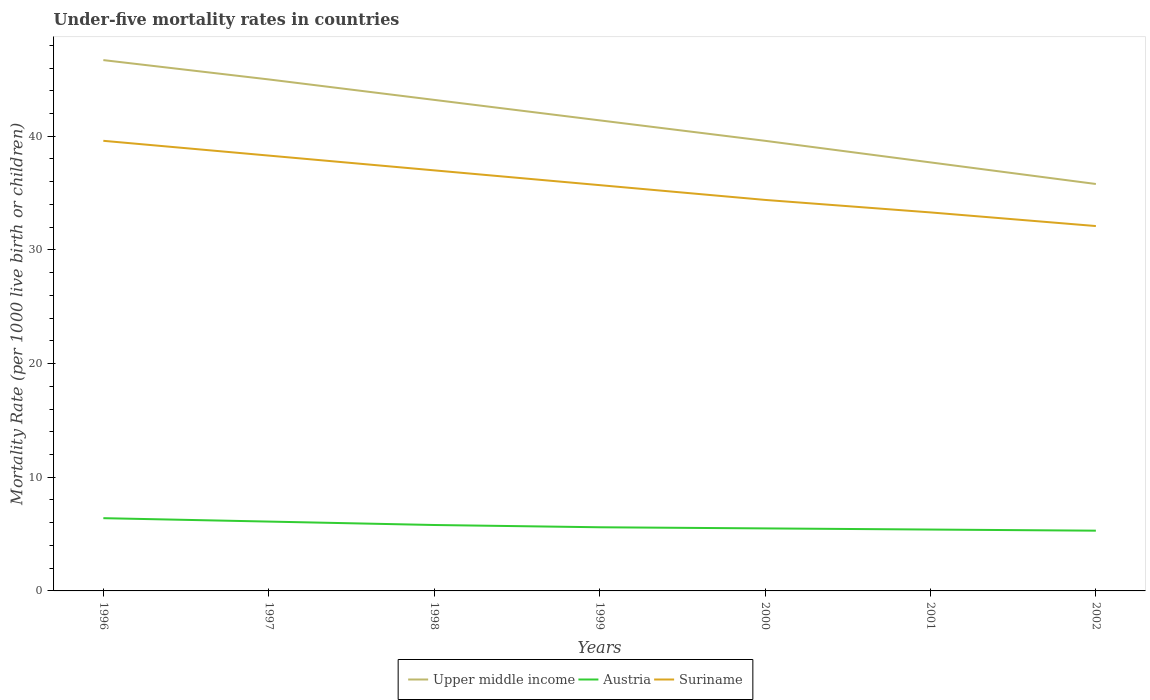How many different coloured lines are there?
Your answer should be compact. 3. Does the line corresponding to Austria intersect with the line corresponding to Suriname?
Offer a very short reply. No. Is the number of lines equal to the number of legend labels?
Make the answer very short. Yes. Across all years, what is the maximum under-five mortality rate in Suriname?
Give a very brief answer. 32.1. What is the total under-five mortality rate in Upper middle income in the graph?
Ensure brevity in your answer.  3.6. What is the difference between the highest and the second highest under-five mortality rate in Austria?
Give a very brief answer. 1.1. How many years are there in the graph?
Give a very brief answer. 7. Does the graph contain grids?
Provide a succinct answer. No. Where does the legend appear in the graph?
Provide a succinct answer. Bottom center. How many legend labels are there?
Provide a succinct answer. 3. How are the legend labels stacked?
Keep it short and to the point. Horizontal. What is the title of the graph?
Your answer should be compact. Under-five mortality rates in countries. Does "Bolivia" appear as one of the legend labels in the graph?
Your response must be concise. No. What is the label or title of the Y-axis?
Make the answer very short. Mortality Rate (per 1000 live birth or children). What is the Mortality Rate (per 1000 live birth or children) of Upper middle income in 1996?
Keep it short and to the point. 46.7. What is the Mortality Rate (per 1000 live birth or children) in Austria in 1996?
Ensure brevity in your answer.  6.4. What is the Mortality Rate (per 1000 live birth or children) in Suriname in 1996?
Provide a succinct answer. 39.6. What is the Mortality Rate (per 1000 live birth or children) of Upper middle income in 1997?
Provide a short and direct response. 45. What is the Mortality Rate (per 1000 live birth or children) of Suriname in 1997?
Offer a terse response. 38.3. What is the Mortality Rate (per 1000 live birth or children) of Upper middle income in 1998?
Make the answer very short. 43.2. What is the Mortality Rate (per 1000 live birth or children) in Suriname in 1998?
Make the answer very short. 37. What is the Mortality Rate (per 1000 live birth or children) in Upper middle income in 1999?
Provide a short and direct response. 41.4. What is the Mortality Rate (per 1000 live birth or children) in Austria in 1999?
Provide a short and direct response. 5.6. What is the Mortality Rate (per 1000 live birth or children) in Suriname in 1999?
Offer a very short reply. 35.7. What is the Mortality Rate (per 1000 live birth or children) of Upper middle income in 2000?
Your answer should be very brief. 39.6. What is the Mortality Rate (per 1000 live birth or children) in Suriname in 2000?
Your answer should be compact. 34.4. What is the Mortality Rate (per 1000 live birth or children) in Upper middle income in 2001?
Provide a succinct answer. 37.7. What is the Mortality Rate (per 1000 live birth or children) of Suriname in 2001?
Give a very brief answer. 33.3. What is the Mortality Rate (per 1000 live birth or children) of Upper middle income in 2002?
Your answer should be very brief. 35.8. What is the Mortality Rate (per 1000 live birth or children) of Austria in 2002?
Ensure brevity in your answer.  5.3. What is the Mortality Rate (per 1000 live birth or children) of Suriname in 2002?
Ensure brevity in your answer.  32.1. Across all years, what is the maximum Mortality Rate (per 1000 live birth or children) in Upper middle income?
Your response must be concise. 46.7. Across all years, what is the maximum Mortality Rate (per 1000 live birth or children) in Suriname?
Ensure brevity in your answer.  39.6. Across all years, what is the minimum Mortality Rate (per 1000 live birth or children) in Upper middle income?
Give a very brief answer. 35.8. Across all years, what is the minimum Mortality Rate (per 1000 live birth or children) in Austria?
Ensure brevity in your answer.  5.3. Across all years, what is the minimum Mortality Rate (per 1000 live birth or children) of Suriname?
Keep it short and to the point. 32.1. What is the total Mortality Rate (per 1000 live birth or children) of Upper middle income in the graph?
Offer a very short reply. 289.4. What is the total Mortality Rate (per 1000 live birth or children) in Austria in the graph?
Your response must be concise. 40.1. What is the total Mortality Rate (per 1000 live birth or children) in Suriname in the graph?
Your response must be concise. 250.4. What is the difference between the Mortality Rate (per 1000 live birth or children) of Suriname in 1996 and that in 1997?
Make the answer very short. 1.3. What is the difference between the Mortality Rate (per 1000 live birth or children) of Upper middle income in 1996 and that in 1998?
Provide a succinct answer. 3.5. What is the difference between the Mortality Rate (per 1000 live birth or children) in Austria in 1996 and that in 1998?
Offer a very short reply. 0.6. What is the difference between the Mortality Rate (per 1000 live birth or children) in Austria in 1996 and that in 1999?
Provide a succinct answer. 0.8. What is the difference between the Mortality Rate (per 1000 live birth or children) in Suriname in 1996 and that in 1999?
Ensure brevity in your answer.  3.9. What is the difference between the Mortality Rate (per 1000 live birth or children) in Austria in 1996 and that in 2000?
Offer a very short reply. 0.9. What is the difference between the Mortality Rate (per 1000 live birth or children) in Suriname in 1996 and that in 2000?
Your response must be concise. 5.2. What is the difference between the Mortality Rate (per 1000 live birth or children) of Upper middle income in 1996 and that in 2001?
Your response must be concise. 9. What is the difference between the Mortality Rate (per 1000 live birth or children) in Austria in 1996 and that in 2001?
Make the answer very short. 1. What is the difference between the Mortality Rate (per 1000 live birth or children) in Suriname in 1996 and that in 2001?
Keep it short and to the point. 6.3. What is the difference between the Mortality Rate (per 1000 live birth or children) of Upper middle income in 1996 and that in 2002?
Ensure brevity in your answer.  10.9. What is the difference between the Mortality Rate (per 1000 live birth or children) of Austria in 1996 and that in 2002?
Your answer should be compact. 1.1. What is the difference between the Mortality Rate (per 1000 live birth or children) in Upper middle income in 1997 and that in 1998?
Make the answer very short. 1.8. What is the difference between the Mortality Rate (per 1000 live birth or children) of Austria in 1997 and that in 1998?
Give a very brief answer. 0.3. What is the difference between the Mortality Rate (per 1000 live birth or children) in Suriname in 1997 and that in 1998?
Ensure brevity in your answer.  1.3. What is the difference between the Mortality Rate (per 1000 live birth or children) in Austria in 1997 and that in 1999?
Ensure brevity in your answer.  0.5. What is the difference between the Mortality Rate (per 1000 live birth or children) in Suriname in 1997 and that in 1999?
Provide a short and direct response. 2.6. What is the difference between the Mortality Rate (per 1000 live birth or children) in Upper middle income in 1997 and that in 2000?
Make the answer very short. 5.4. What is the difference between the Mortality Rate (per 1000 live birth or children) in Austria in 1997 and that in 2000?
Provide a short and direct response. 0.6. What is the difference between the Mortality Rate (per 1000 live birth or children) of Upper middle income in 1997 and that in 2001?
Give a very brief answer. 7.3. What is the difference between the Mortality Rate (per 1000 live birth or children) in Austria in 1997 and that in 2001?
Your answer should be very brief. 0.7. What is the difference between the Mortality Rate (per 1000 live birth or children) of Upper middle income in 1997 and that in 2002?
Provide a succinct answer. 9.2. What is the difference between the Mortality Rate (per 1000 live birth or children) of Austria in 1997 and that in 2002?
Ensure brevity in your answer.  0.8. What is the difference between the Mortality Rate (per 1000 live birth or children) in Upper middle income in 1998 and that in 1999?
Your answer should be compact. 1.8. What is the difference between the Mortality Rate (per 1000 live birth or children) of Austria in 1998 and that in 1999?
Offer a terse response. 0.2. What is the difference between the Mortality Rate (per 1000 live birth or children) in Suriname in 1998 and that in 1999?
Your answer should be compact. 1.3. What is the difference between the Mortality Rate (per 1000 live birth or children) in Austria in 1998 and that in 2000?
Your response must be concise. 0.3. What is the difference between the Mortality Rate (per 1000 live birth or children) in Austria in 1998 and that in 2001?
Your response must be concise. 0.4. What is the difference between the Mortality Rate (per 1000 live birth or children) in Suriname in 1998 and that in 2001?
Your response must be concise. 3.7. What is the difference between the Mortality Rate (per 1000 live birth or children) in Upper middle income in 1998 and that in 2002?
Your response must be concise. 7.4. What is the difference between the Mortality Rate (per 1000 live birth or children) in Austria in 1998 and that in 2002?
Provide a succinct answer. 0.5. What is the difference between the Mortality Rate (per 1000 live birth or children) in Suriname in 1998 and that in 2002?
Offer a terse response. 4.9. What is the difference between the Mortality Rate (per 1000 live birth or children) in Upper middle income in 1999 and that in 2000?
Your response must be concise. 1.8. What is the difference between the Mortality Rate (per 1000 live birth or children) in Austria in 1999 and that in 2000?
Keep it short and to the point. 0.1. What is the difference between the Mortality Rate (per 1000 live birth or children) in Suriname in 1999 and that in 2000?
Keep it short and to the point. 1.3. What is the difference between the Mortality Rate (per 1000 live birth or children) in Upper middle income in 1999 and that in 2002?
Ensure brevity in your answer.  5.6. What is the difference between the Mortality Rate (per 1000 live birth or children) in Suriname in 1999 and that in 2002?
Provide a short and direct response. 3.6. What is the difference between the Mortality Rate (per 1000 live birth or children) in Austria in 2000 and that in 2001?
Provide a succinct answer. 0.1. What is the difference between the Mortality Rate (per 1000 live birth or children) of Suriname in 2000 and that in 2001?
Ensure brevity in your answer.  1.1. What is the difference between the Mortality Rate (per 1000 live birth or children) in Austria in 2000 and that in 2002?
Your answer should be very brief. 0.2. What is the difference between the Mortality Rate (per 1000 live birth or children) of Upper middle income in 2001 and that in 2002?
Make the answer very short. 1.9. What is the difference between the Mortality Rate (per 1000 live birth or children) of Suriname in 2001 and that in 2002?
Ensure brevity in your answer.  1.2. What is the difference between the Mortality Rate (per 1000 live birth or children) in Upper middle income in 1996 and the Mortality Rate (per 1000 live birth or children) in Austria in 1997?
Give a very brief answer. 40.6. What is the difference between the Mortality Rate (per 1000 live birth or children) in Austria in 1996 and the Mortality Rate (per 1000 live birth or children) in Suriname in 1997?
Keep it short and to the point. -31.9. What is the difference between the Mortality Rate (per 1000 live birth or children) in Upper middle income in 1996 and the Mortality Rate (per 1000 live birth or children) in Austria in 1998?
Your response must be concise. 40.9. What is the difference between the Mortality Rate (per 1000 live birth or children) of Austria in 1996 and the Mortality Rate (per 1000 live birth or children) of Suriname in 1998?
Make the answer very short. -30.6. What is the difference between the Mortality Rate (per 1000 live birth or children) of Upper middle income in 1996 and the Mortality Rate (per 1000 live birth or children) of Austria in 1999?
Provide a short and direct response. 41.1. What is the difference between the Mortality Rate (per 1000 live birth or children) of Austria in 1996 and the Mortality Rate (per 1000 live birth or children) of Suriname in 1999?
Make the answer very short. -29.3. What is the difference between the Mortality Rate (per 1000 live birth or children) in Upper middle income in 1996 and the Mortality Rate (per 1000 live birth or children) in Austria in 2000?
Your answer should be very brief. 41.2. What is the difference between the Mortality Rate (per 1000 live birth or children) of Upper middle income in 1996 and the Mortality Rate (per 1000 live birth or children) of Suriname in 2000?
Keep it short and to the point. 12.3. What is the difference between the Mortality Rate (per 1000 live birth or children) in Austria in 1996 and the Mortality Rate (per 1000 live birth or children) in Suriname in 2000?
Offer a very short reply. -28. What is the difference between the Mortality Rate (per 1000 live birth or children) of Upper middle income in 1996 and the Mortality Rate (per 1000 live birth or children) of Austria in 2001?
Provide a succinct answer. 41.3. What is the difference between the Mortality Rate (per 1000 live birth or children) of Upper middle income in 1996 and the Mortality Rate (per 1000 live birth or children) of Suriname in 2001?
Give a very brief answer. 13.4. What is the difference between the Mortality Rate (per 1000 live birth or children) in Austria in 1996 and the Mortality Rate (per 1000 live birth or children) in Suriname in 2001?
Ensure brevity in your answer.  -26.9. What is the difference between the Mortality Rate (per 1000 live birth or children) in Upper middle income in 1996 and the Mortality Rate (per 1000 live birth or children) in Austria in 2002?
Offer a very short reply. 41.4. What is the difference between the Mortality Rate (per 1000 live birth or children) in Upper middle income in 1996 and the Mortality Rate (per 1000 live birth or children) in Suriname in 2002?
Offer a very short reply. 14.6. What is the difference between the Mortality Rate (per 1000 live birth or children) in Austria in 1996 and the Mortality Rate (per 1000 live birth or children) in Suriname in 2002?
Offer a terse response. -25.7. What is the difference between the Mortality Rate (per 1000 live birth or children) in Upper middle income in 1997 and the Mortality Rate (per 1000 live birth or children) in Austria in 1998?
Offer a very short reply. 39.2. What is the difference between the Mortality Rate (per 1000 live birth or children) of Austria in 1997 and the Mortality Rate (per 1000 live birth or children) of Suriname in 1998?
Offer a terse response. -30.9. What is the difference between the Mortality Rate (per 1000 live birth or children) of Upper middle income in 1997 and the Mortality Rate (per 1000 live birth or children) of Austria in 1999?
Make the answer very short. 39.4. What is the difference between the Mortality Rate (per 1000 live birth or children) of Upper middle income in 1997 and the Mortality Rate (per 1000 live birth or children) of Suriname in 1999?
Provide a short and direct response. 9.3. What is the difference between the Mortality Rate (per 1000 live birth or children) of Austria in 1997 and the Mortality Rate (per 1000 live birth or children) of Suriname in 1999?
Keep it short and to the point. -29.6. What is the difference between the Mortality Rate (per 1000 live birth or children) in Upper middle income in 1997 and the Mortality Rate (per 1000 live birth or children) in Austria in 2000?
Keep it short and to the point. 39.5. What is the difference between the Mortality Rate (per 1000 live birth or children) of Austria in 1997 and the Mortality Rate (per 1000 live birth or children) of Suriname in 2000?
Keep it short and to the point. -28.3. What is the difference between the Mortality Rate (per 1000 live birth or children) of Upper middle income in 1997 and the Mortality Rate (per 1000 live birth or children) of Austria in 2001?
Make the answer very short. 39.6. What is the difference between the Mortality Rate (per 1000 live birth or children) in Austria in 1997 and the Mortality Rate (per 1000 live birth or children) in Suriname in 2001?
Ensure brevity in your answer.  -27.2. What is the difference between the Mortality Rate (per 1000 live birth or children) of Upper middle income in 1997 and the Mortality Rate (per 1000 live birth or children) of Austria in 2002?
Give a very brief answer. 39.7. What is the difference between the Mortality Rate (per 1000 live birth or children) in Upper middle income in 1997 and the Mortality Rate (per 1000 live birth or children) in Suriname in 2002?
Provide a succinct answer. 12.9. What is the difference between the Mortality Rate (per 1000 live birth or children) of Austria in 1997 and the Mortality Rate (per 1000 live birth or children) of Suriname in 2002?
Provide a succinct answer. -26. What is the difference between the Mortality Rate (per 1000 live birth or children) of Upper middle income in 1998 and the Mortality Rate (per 1000 live birth or children) of Austria in 1999?
Make the answer very short. 37.6. What is the difference between the Mortality Rate (per 1000 live birth or children) of Austria in 1998 and the Mortality Rate (per 1000 live birth or children) of Suriname in 1999?
Your answer should be very brief. -29.9. What is the difference between the Mortality Rate (per 1000 live birth or children) of Upper middle income in 1998 and the Mortality Rate (per 1000 live birth or children) of Austria in 2000?
Ensure brevity in your answer.  37.7. What is the difference between the Mortality Rate (per 1000 live birth or children) in Austria in 1998 and the Mortality Rate (per 1000 live birth or children) in Suriname in 2000?
Ensure brevity in your answer.  -28.6. What is the difference between the Mortality Rate (per 1000 live birth or children) in Upper middle income in 1998 and the Mortality Rate (per 1000 live birth or children) in Austria in 2001?
Give a very brief answer. 37.8. What is the difference between the Mortality Rate (per 1000 live birth or children) of Austria in 1998 and the Mortality Rate (per 1000 live birth or children) of Suriname in 2001?
Give a very brief answer. -27.5. What is the difference between the Mortality Rate (per 1000 live birth or children) in Upper middle income in 1998 and the Mortality Rate (per 1000 live birth or children) in Austria in 2002?
Ensure brevity in your answer.  37.9. What is the difference between the Mortality Rate (per 1000 live birth or children) in Upper middle income in 1998 and the Mortality Rate (per 1000 live birth or children) in Suriname in 2002?
Offer a terse response. 11.1. What is the difference between the Mortality Rate (per 1000 live birth or children) in Austria in 1998 and the Mortality Rate (per 1000 live birth or children) in Suriname in 2002?
Provide a succinct answer. -26.3. What is the difference between the Mortality Rate (per 1000 live birth or children) of Upper middle income in 1999 and the Mortality Rate (per 1000 live birth or children) of Austria in 2000?
Keep it short and to the point. 35.9. What is the difference between the Mortality Rate (per 1000 live birth or children) of Austria in 1999 and the Mortality Rate (per 1000 live birth or children) of Suriname in 2000?
Offer a very short reply. -28.8. What is the difference between the Mortality Rate (per 1000 live birth or children) in Austria in 1999 and the Mortality Rate (per 1000 live birth or children) in Suriname in 2001?
Keep it short and to the point. -27.7. What is the difference between the Mortality Rate (per 1000 live birth or children) in Upper middle income in 1999 and the Mortality Rate (per 1000 live birth or children) in Austria in 2002?
Ensure brevity in your answer.  36.1. What is the difference between the Mortality Rate (per 1000 live birth or children) of Upper middle income in 1999 and the Mortality Rate (per 1000 live birth or children) of Suriname in 2002?
Your response must be concise. 9.3. What is the difference between the Mortality Rate (per 1000 live birth or children) of Austria in 1999 and the Mortality Rate (per 1000 live birth or children) of Suriname in 2002?
Make the answer very short. -26.5. What is the difference between the Mortality Rate (per 1000 live birth or children) of Upper middle income in 2000 and the Mortality Rate (per 1000 live birth or children) of Austria in 2001?
Ensure brevity in your answer.  34.2. What is the difference between the Mortality Rate (per 1000 live birth or children) in Upper middle income in 2000 and the Mortality Rate (per 1000 live birth or children) in Suriname in 2001?
Your response must be concise. 6.3. What is the difference between the Mortality Rate (per 1000 live birth or children) in Austria in 2000 and the Mortality Rate (per 1000 live birth or children) in Suriname in 2001?
Keep it short and to the point. -27.8. What is the difference between the Mortality Rate (per 1000 live birth or children) of Upper middle income in 2000 and the Mortality Rate (per 1000 live birth or children) of Austria in 2002?
Offer a very short reply. 34.3. What is the difference between the Mortality Rate (per 1000 live birth or children) of Austria in 2000 and the Mortality Rate (per 1000 live birth or children) of Suriname in 2002?
Provide a short and direct response. -26.6. What is the difference between the Mortality Rate (per 1000 live birth or children) of Upper middle income in 2001 and the Mortality Rate (per 1000 live birth or children) of Austria in 2002?
Your response must be concise. 32.4. What is the difference between the Mortality Rate (per 1000 live birth or children) in Upper middle income in 2001 and the Mortality Rate (per 1000 live birth or children) in Suriname in 2002?
Offer a very short reply. 5.6. What is the difference between the Mortality Rate (per 1000 live birth or children) of Austria in 2001 and the Mortality Rate (per 1000 live birth or children) of Suriname in 2002?
Your answer should be compact. -26.7. What is the average Mortality Rate (per 1000 live birth or children) of Upper middle income per year?
Offer a terse response. 41.34. What is the average Mortality Rate (per 1000 live birth or children) in Austria per year?
Your response must be concise. 5.73. What is the average Mortality Rate (per 1000 live birth or children) in Suriname per year?
Your answer should be very brief. 35.77. In the year 1996, what is the difference between the Mortality Rate (per 1000 live birth or children) in Upper middle income and Mortality Rate (per 1000 live birth or children) in Austria?
Give a very brief answer. 40.3. In the year 1996, what is the difference between the Mortality Rate (per 1000 live birth or children) in Austria and Mortality Rate (per 1000 live birth or children) in Suriname?
Offer a terse response. -33.2. In the year 1997, what is the difference between the Mortality Rate (per 1000 live birth or children) in Upper middle income and Mortality Rate (per 1000 live birth or children) in Austria?
Your answer should be very brief. 38.9. In the year 1997, what is the difference between the Mortality Rate (per 1000 live birth or children) of Upper middle income and Mortality Rate (per 1000 live birth or children) of Suriname?
Your answer should be very brief. 6.7. In the year 1997, what is the difference between the Mortality Rate (per 1000 live birth or children) of Austria and Mortality Rate (per 1000 live birth or children) of Suriname?
Offer a terse response. -32.2. In the year 1998, what is the difference between the Mortality Rate (per 1000 live birth or children) of Upper middle income and Mortality Rate (per 1000 live birth or children) of Austria?
Offer a terse response. 37.4. In the year 1998, what is the difference between the Mortality Rate (per 1000 live birth or children) of Austria and Mortality Rate (per 1000 live birth or children) of Suriname?
Your response must be concise. -31.2. In the year 1999, what is the difference between the Mortality Rate (per 1000 live birth or children) in Upper middle income and Mortality Rate (per 1000 live birth or children) in Austria?
Offer a very short reply. 35.8. In the year 1999, what is the difference between the Mortality Rate (per 1000 live birth or children) of Austria and Mortality Rate (per 1000 live birth or children) of Suriname?
Offer a very short reply. -30.1. In the year 2000, what is the difference between the Mortality Rate (per 1000 live birth or children) of Upper middle income and Mortality Rate (per 1000 live birth or children) of Austria?
Offer a very short reply. 34.1. In the year 2000, what is the difference between the Mortality Rate (per 1000 live birth or children) of Austria and Mortality Rate (per 1000 live birth or children) of Suriname?
Your response must be concise. -28.9. In the year 2001, what is the difference between the Mortality Rate (per 1000 live birth or children) of Upper middle income and Mortality Rate (per 1000 live birth or children) of Austria?
Offer a very short reply. 32.3. In the year 2001, what is the difference between the Mortality Rate (per 1000 live birth or children) in Upper middle income and Mortality Rate (per 1000 live birth or children) in Suriname?
Give a very brief answer. 4.4. In the year 2001, what is the difference between the Mortality Rate (per 1000 live birth or children) of Austria and Mortality Rate (per 1000 live birth or children) of Suriname?
Give a very brief answer. -27.9. In the year 2002, what is the difference between the Mortality Rate (per 1000 live birth or children) of Upper middle income and Mortality Rate (per 1000 live birth or children) of Austria?
Your response must be concise. 30.5. In the year 2002, what is the difference between the Mortality Rate (per 1000 live birth or children) in Upper middle income and Mortality Rate (per 1000 live birth or children) in Suriname?
Ensure brevity in your answer.  3.7. In the year 2002, what is the difference between the Mortality Rate (per 1000 live birth or children) of Austria and Mortality Rate (per 1000 live birth or children) of Suriname?
Offer a terse response. -26.8. What is the ratio of the Mortality Rate (per 1000 live birth or children) of Upper middle income in 1996 to that in 1997?
Your answer should be very brief. 1.04. What is the ratio of the Mortality Rate (per 1000 live birth or children) of Austria in 1996 to that in 1997?
Provide a succinct answer. 1.05. What is the ratio of the Mortality Rate (per 1000 live birth or children) in Suriname in 1996 to that in 1997?
Provide a succinct answer. 1.03. What is the ratio of the Mortality Rate (per 1000 live birth or children) of Upper middle income in 1996 to that in 1998?
Give a very brief answer. 1.08. What is the ratio of the Mortality Rate (per 1000 live birth or children) in Austria in 1996 to that in 1998?
Your response must be concise. 1.1. What is the ratio of the Mortality Rate (per 1000 live birth or children) in Suriname in 1996 to that in 1998?
Offer a very short reply. 1.07. What is the ratio of the Mortality Rate (per 1000 live birth or children) of Upper middle income in 1996 to that in 1999?
Provide a short and direct response. 1.13. What is the ratio of the Mortality Rate (per 1000 live birth or children) of Austria in 1996 to that in 1999?
Your response must be concise. 1.14. What is the ratio of the Mortality Rate (per 1000 live birth or children) of Suriname in 1996 to that in 1999?
Keep it short and to the point. 1.11. What is the ratio of the Mortality Rate (per 1000 live birth or children) of Upper middle income in 1996 to that in 2000?
Your response must be concise. 1.18. What is the ratio of the Mortality Rate (per 1000 live birth or children) in Austria in 1996 to that in 2000?
Ensure brevity in your answer.  1.16. What is the ratio of the Mortality Rate (per 1000 live birth or children) in Suriname in 1996 to that in 2000?
Give a very brief answer. 1.15. What is the ratio of the Mortality Rate (per 1000 live birth or children) in Upper middle income in 1996 to that in 2001?
Ensure brevity in your answer.  1.24. What is the ratio of the Mortality Rate (per 1000 live birth or children) of Austria in 1996 to that in 2001?
Keep it short and to the point. 1.19. What is the ratio of the Mortality Rate (per 1000 live birth or children) in Suriname in 1996 to that in 2001?
Make the answer very short. 1.19. What is the ratio of the Mortality Rate (per 1000 live birth or children) of Upper middle income in 1996 to that in 2002?
Make the answer very short. 1.3. What is the ratio of the Mortality Rate (per 1000 live birth or children) in Austria in 1996 to that in 2002?
Offer a very short reply. 1.21. What is the ratio of the Mortality Rate (per 1000 live birth or children) in Suriname in 1996 to that in 2002?
Make the answer very short. 1.23. What is the ratio of the Mortality Rate (per 1000 live birth or children) of Upper middle income in 1997 to that in 1998?
Your answer should be compact. 1.04. What is the ratio of the Mortality Rate (per 1000 live birth or children) in Austria in 1997 to that in 1998?
Your answer should be compact. 1.05. What is the ratio of the Mortality Rate (per 1000 live birth or children) in Suriname in 1997 to that in 1998?
Offer a very short reply. 1.04. What is the ratio of the Mortality Rate (per 1000 live birth or children) in Upper middle income in 1997 to that in 1999?
Offer a very short reply. 1.09. What is the ratio of the Mortality Rate (per 1000 live birth or children) in Austria in 1997 to that in 1999?
Ensure brevity in your answer.  1.09. What is the ratio of the Mortality Rate (per 1000 live birth or children) in Suriname in 1997 to that in 1999?
Your answer should be compact. 1.07. What is the ratio of the Mortality Rate (per 1000 live birth or children) of Upper middle income in 1997 to that in 2000?
Keep it short and to the point. 1.14. What is the ratio of the Mortality Rate (per 1000 live birth or children) of Austria in 1997 to that in 2000?
Keep it short and to the point. 1.11. What is the ratio of the Mortality Rate (per 1000 live birth or children) of Suriname in 1997 to that in 2000?
Keep it short and to the point. 1.11. What is the ratio of the Mortality Rate (per 1000 live birth or children) of Upper middle income in 1997 to that in 2001?
Offer a terse response. 1.19. What is the ratio of the Mortality Rate (per 1000 live birth or children) in Austria in 1997 to that in 2001?
Offer a terse response. 1.13. What is the ratio of the Mortality Rate (per 1000 live birth or children) in Suriname in 1997 to that in 2001?
Keep it short and to the point. 1.15. What is the ratio of the Mortality Rate (per 1000 live birth or children) in Upper middle income in 1997 to that in 2002?
Ensure brevity in your answer.  1.26. What is the ratio of the Mortality Rate (per 1000 live birth or children) of Austria in 1997 to that in 2002?
Your response must be concise. 1.15. What is the ratio of the Mortality Rate (per 1000 live birth or children) in Suriname in 1997 to that in 2002?
Provide a short and direct response. 1.19. What is the ratio of the Mortality Rate (per 1000 live birth or children) of Upper middle income in 1998 to that in 1999?
Ensure brevity in your answer.  1.04. What is the ratio of the Mortality Rate (per 1000 live birth or children) of Austria in 1998 to that in 1999?
Offer a very short reply. 1.04. What is the ratio of the Mortality Rate (per 1000 live birth or children) of Suriname in 1998 to that in 1999?
Keep it short and to the point. 1.04. What is the ratio of the Mortality Rate (per 1000 live birth or children) in Austria in 1998 to that in 2000?
Give a very brief answer. 1.05. What is the ratio of the Mortality Rate (per 1000 live birth or children) of Suriname in 1998 to that in 2000?
Keep it short and to the point. 1.08. What is the ratio of the Mortality Rate (per 1000 live birth or children) of Upper middle income in 1998 to that in 2001?
Offer a terse response. 1.15. What is the ratio of the Mortality Rate (per 1000 live birth or children) in Austria in 1998 to that in 2001?
Give a very brief answer. 1.07. What is the ratio of the Mortality Rate (per 1000 live birth or children) in Upper middle income in 1998 to that in 2002?
Your response must be concise. 1.21. What is the ratio of the Mortality Rate (per 1000 live birth or children) in Austria in 1998 to that in 2002?
Give a very brief answer. 1.09. What is the ratio of the Mortality Rate (per 1000 live birth or children) of Suriname in 1998 to that in 2002?
Offer a terse response. 1.15. What is the ratio of the Mortality Rate (per 1000 live birth or children) of Upper middle income in 1999 to that in 2000?
Offer a terse response. 1.05. What is the ratio of the Mortality Rate (per 1000 live birth or children) in Austria in 1999 to that in 2000?
Provide a short and direct response. 1.02. What is the ratio of the Mortality Rate (per 1000 live birth or children) in Suriname in 1999 to that in 2000?
Give a very brief answer. 1.04. What is the ratio of the Mortality Rate (per 1000 live birth or children) of Upper middle income in 1999 to that in 2001?
Offer a very short reply. 1.1. What is the ratio of the Mortality Rate (per 1000 live birth or children) of Austria in 1999 to that in 2001?
Ensure brevity in your answer.  1.04. What is the ratio of the Mortality Rate (per 1000 live birth or children) of Suriname in 1999 to that in 2001?
Give a very brief answer. 1.07. What is the ratio of the Mortality Rate (per 1000 live birth or children) of Upper middle income in 1999 to that in 2002?
Provide a short and direct response. 1.16. What is the ratio of the Mortality Rate (per 1000 live birth or children) of Austria in 1999 to that in 2002?
Your answer should be very brief. 1.06. What is the ratio of the Mortality Rate (per 1000 live birth or children) in Suriname in 1999 to that in 2002?
Give a very brief answer. 1.11. What is the ratio of the Mortality Rate (per 1000 live birth or children) of Upper middle income in 2000 to that in 2001?
Your answer should be compact. 1.05. What is the ratio of the Mortality Rate (per 1000 live birth or children) of Austria in 2000 to that in 2001?
Keep it short and to the point. 1.02. What is the ratio of the Mortality Rate (per 1000 live birth or children) of Suriname in 2000 to that in 2001?
Offer a very short reply. 1.03. What is the ratio of the Mortality Rate (per 1000 live birth or children) in Upper middle income in 2000 to that in 2002?
Your answer should be compact. 1.11. What is the ratio of the Mortality Rate (per 1000 live birth or children) in Austria in 2000 to that in 2002?
Offer a very short reply. 1.04. What is the ratio of the Mortality Rate (per 1000 live birth or children) in Suriname in 2000 to that in 2002?
Your answer should be compact. 1.07. What is the ratio of the Mortality Rate (per 1000 live birth or children) of Upper middle income in 2001 to that in 2002?
Offer a terse response. 1.05. What is the ratio of the Mortality Rate (per 1000 live birth or children) in Austria in 2001 to that in 2002?
Offer a terse response. 1.02. What is the ratio of the Mortality Rate (per 1000 live birth or children) in Suriname in 2001 to that in 2002?
Make the answer very short. 1.04. What is the difference between the highest and the second highest Mortality Rate (per 1000 live birth or children) of Austria?
Provide a succinct answer. 0.3. What is the difference between the highest and the second highest Mortality Rate (per 1000 live birth or children) in Suriname?
Give a very brief answer. 1.3. What is the difference between the highest and the lowest Mortality Rate (per 1000 live birth or children) in Upper middle income?
Make the answer very short. 10.9. What is the difference between the highest and the lowest Mortality Rate (per 1000 live birth or children) in Suriname?
Ensure brevity in your answer.  7.5. 